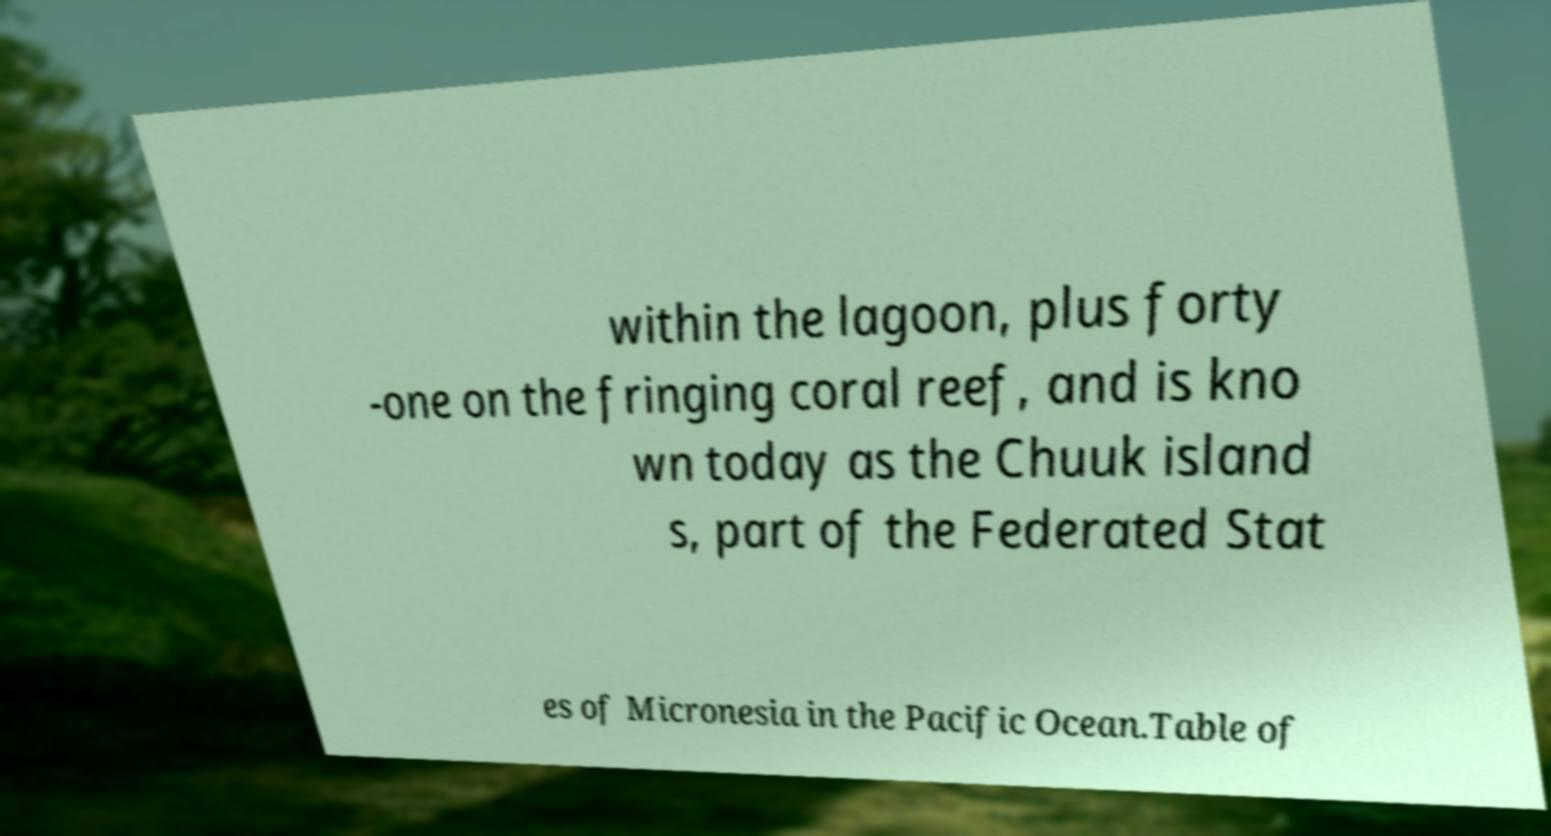Could you extract and type out the text from this image? within the lagoon, plus forty -one on the fringing coral reef, and is kno wn today as the Chuuk island s, part of the Federated Stat es of Micronesia in the Pacific Ocean.Table of 